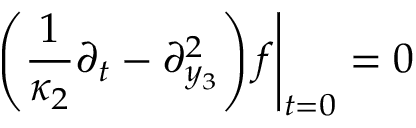Convert formula to latex. <formula><loc_0><loc_0><loc_500><loc_500>\left ( \frac { 1 } { \kappa _ { 2 } } \partial _ { t } - \partial _ { y _ { 3 } } ^ { 2 } \right ) f \right | _ { t = 0 } = 0</formula> 